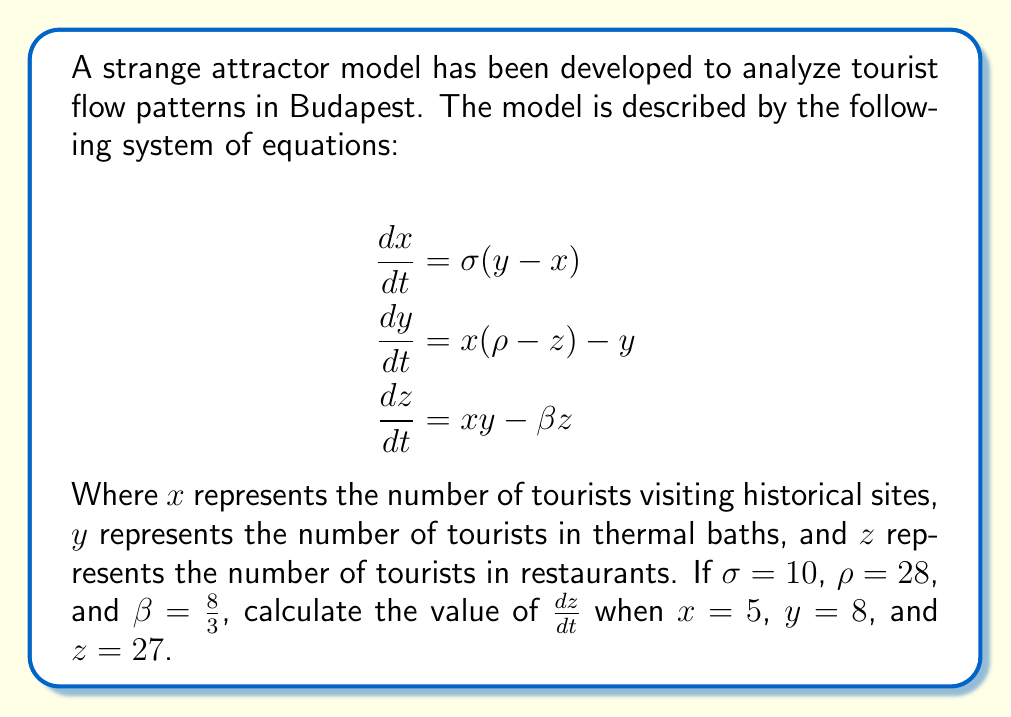Give your solution to this math problem. To solve this problem, we need to follow these steps:

1. Identify the equation for $\frac{dz}{dt}$:
   $$\frac{dz}{dt} = xy - \beta z$$

2. Substitute the given values:
   $x = 5$
   $y = 8$
   $z = 27$
   $\beta = \frac{8}{3}$

3. Calculate $xy$:
   $xy = 5 \times 8 = 40$

4. Calculate $\beta z$:
   $\beta z = \frac{8}{3} \times 27 = 72$

5. Apply the equation:
   $$\begin{align}
   \frac{dz}{dt} &= xy - \beta z \\
   &= 40 - 72 \\
   &= -32
   \end{align}$$

Therefore, the rate of change in the number of tourists in restaurants ($\frac{dz}{dt}$) is -32 tourists per unit time.
Answer: $-32$ 